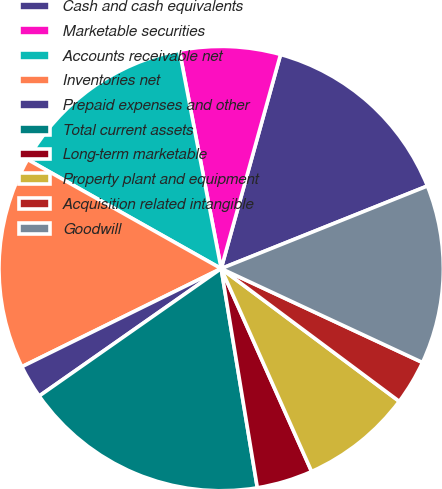<chart> <loc_0><loc_0><loc_500><loc_500><pie_chart><fcel>Cash and cash equivalents<fcel>Marketable securities<fcel>Accounts receivable net<fcel>Inventories net<fcel>Prepaid expenses and other<fcel>Total current assets<fcel>Long-term marketable<fcel>Property plant and equipment<fcel>Acquisition related intangible<fcel>Goodwill<nl><fcel>14.63%<fcel>7.32%<fcel>13.82%<fcel>15.45%<fcel>2.44%<fcel>17.88%<fcel>4.07%<fcel>8.13%<fcel>3.25%<fcel>13.01%<nl></chart> 